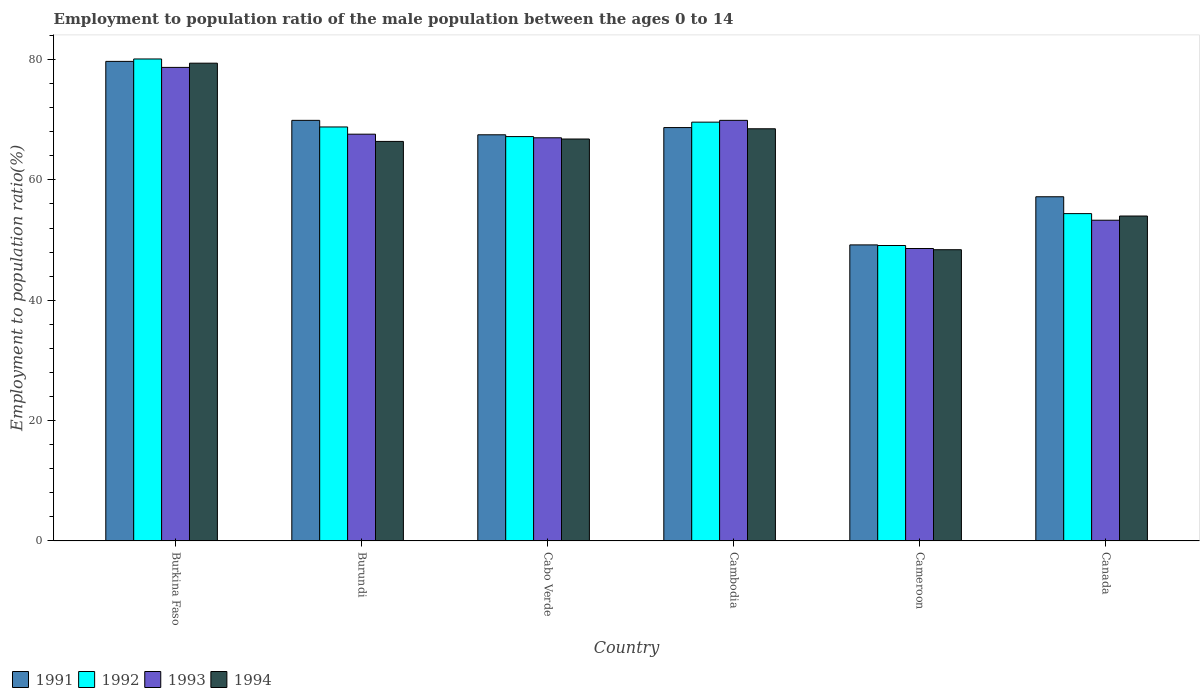How many different coloured bars are there?
Ensure brevity in your answer.  4. How many bars are there on the 5th tick from the left?
Give a very brief answer. 4. What is the label of the 3rd group of bars from the left?
Offer a terse response. Cabo Verde. What is the employment to population ratio in 1993 in Canada?
Give a very brief answer. 53.3. Across all countries, what is the maximum employment to population ratio in 1993?
Offer a terse response. 78.7. Across all countries, what is the minimum employment to population ratio in 1992?
Offer a very short reply. 49.1. In which country was the employment to population ratio in 1994 maximum?
Give a very brief answer. Burkina Faso. In which country was the employment to population ratio in 1993 minimum?
Ensure brevity in your answer.  Cameroon. What is the total employment to population ratio in 1993 in the graph?
Offer a very short reply. 385.1. What is the difference between the employment to population ratio in 1994 in Cabo Verde and that in Cameroon?
Keep it short and to the point. 18.4. What is the difference between the employment to population ratio in 1992 in Canada and the employment to population ratio in 1991 in Cabo Verde?
Provide a succinct answer. -13.1. What is the average employment to population ratio in 1991 per country?
Offer a terse response. 65.37. What is the difference between the employment to population ratio of/in 1991 and employment to population ratio of/in 1994 in Burkina Faso?
Provide a succinct answer. 0.3. In how many countries, is the employment to population ratio in 1993 greater than 24 %?
Your response must be concise. 6. What is the ratio of the employment to population ratio in 1994 in Burundi to that in Cambodia?
Keep it short and to the point. 0.97. Is the difference between the employment to population ratio in 1991 in Cambodia and Canada greater than the difference between the employment to population ratio in 1994 in Cambodia and Canada?
Your answer should be very brief. No. What is the difference between the highest and the second highest employment to population ratio in 1992?
Make the answer very short. 11.3. What is the difference between the highest and the lowest employment to population ratio in 1994?
Your response must be concise. 31. In how many countries, is the employment to population ratio in 1992 greater than the average employment to population ratio in 1992 taken over all countries?
Give a very brief answer. 4. Is the sum of the employment to population ratio in 1993 in Burundi and Cambodia greater than the maximum employment to population ratio in 1991 across all countries?
Offer a very short reply. Yes. Is it the case that in every country, the sum of the employment to population ratio in 1992 and employment to population ratio in 1991 is greater than the sum of employment to population ratio in 1994 and employment to population ratio in 1993?
Your answer should be compact. No. What does the 3rd bar from the left in Burkina Faso represents?
Provide a short and direct response. 1993. How many bars are there?
Keep it short and to the point. 24. How many countries are there in the graph?
Make the answer very short. 6. What is the difference between two consecutive major ticks on the Y-axis?
Offer a terse response. 20. Are the values on the major ticks of Y-axis written in scientific E-notation?
Keep it short and to the point. No. Does the graph contain grids?
Offer a very short reply. No. Where does the legend appear in the graph?
Give a very brief answer. Bottom left. How are the legend labels stacked?
Provide a short and direct response. Horizontal. What is the title of the graph?
Offer a very short reply. Employment to population ratio of the male population between the ages 0 to 14. What is the Employment to population ratio(%) in 1991 in Burkina Faso?
Your response must be concise. 79.7. What is the Employment to population ratio(%) in 1992 in Burkina Faso?
Keep it short and to the point. 80.1. What is the Employment to population ratio(%) in 1993 in Burkina Faso?
Offer a very short reply. 78.7. What is the Employment to population ratio(%) of 1994 in Burkina Faso?
Give a very brief answer. 79.4. What is the Employment to population ratio(%) in 1991 in Burundi?
Offer a terse response. 69.9. What is the Employment to population ratio(%) in 1992 in Burundi?
Give a very brief answer. 68.8. What is the Employment to population ratio(%) in 1993 in Burundi?
Provide a succinct answer. 67.6. What is the Employment to population ratio(%) in 1994 in Burundi?
Your answer should be compact. 66.4. What is the Employment to population ratio(%) in 1991 in Cabo Verde?
Offer a terse response. 67.5. What is the Employment to population ratio(%) of 1992 in Cabo Verde?
Your response must be concise. 67.2. What is the Employment to population ratio(%) of 1994 in Cabo Verde?
Offer a very short reply. 66.8. What is the Employment to population ratio(%) in 1991 in Cambodia?
Make the answer very short. 68.7. What is the Employment to population ratio(%) of 1992 in Cambodia?
Your answer should be compact. 69.6. What is the Employment to population ratio(%) in 1993 in Cambodia?
Make the answer very short. 69.9. What is the Employment to population ratio(%) in 1994 in Cambodia?
Give a very brief answer. 68.5. What is the Employment to population ratio(%) of 1991 in Cameroon?
Your answer should be very brief. 49.2. What is the Employment to population ratio(%) of 1992 in Cameroon?
Make the answer very short. 49.1. What is the Employment to population ratio(%) in 1993 in Cameroon?
Provide a succinct answer. 48.6. What is the Employment to population ratio(%) in 1994 in Cameroon?
Your response must be concise. 48.4. What is the Employment to population ratio(%) of 1991 in Canada?
Provide a succinct answer. 57.2. What is the Employment to population ratio(%) of 1992 in Canada?
Offer a very short reply. 54.4. What is the Employment to population ratio(%) of 1993 in Canada?
Offer a very short reply. 53.3. What is the Employment to population ratio(%) of 1994 in Canada?
Offer a terse response. 54. Across all countries, what is the maximum Employment to population ratio(%) of 1991?
Offer a very short reply. 79.7. Across all countries, what is the maximum Employment to population ratio(%) in 1992?
Your answer should be very brief. 80.1. Across all countries, what is the maximum Employment to population ratio(%) in 1993?
Offer a very short reply. 78.7. Across all countries, what is the maximum Employment to population ratio(%) of 1994?
Your answer should be compact. 79.4. Across all countries, what is the minimum Employment to population ratio(%) in 1991?
Make the answer very short. 49.2. Across all countries, what is the minimum Employment to population ratio(%) in 1992?
Your answer should be compact. 49.1. Across all countries, what is the minimum Employment to population ratio(%) in 1993?
Keep it short and to the point. 48.6. Across all countries, what is the minimum Employment to population ratio(%) in 1994?
Provide a short and direct response. 48.4. What is the total Employment to population ratio(%) in 1991 in the graph?
Your answer should be compact. 392.2. What is the total Employment to population ratio(%) in 1992 in the graph?
Provide a succinct answer. 389.2. What is the total Employment to population ratio(%) of 1993 in the graph?
Your response must be concise. 385.1. What is the total Employment to population ratio(%) in 1994 in the graph?
Offer a very short reply. 383.5. What is the difference between the Employment to population ratio(%) in 1991 in Burkina Faso and that in Burundi?
Provide a short and direct response. 9.8. What is the difference between the Employment to population ratio(%) of 1994 in Burkina Faso and that in Burundi?
Offer a very short reply. 13. What is the difference between the Employment to population ratio(%) of 1992 in Burkina Faso and that in Cabo Verde?
Your response must be concise. 12.9. What is the difference between the Employment to population ratio(%) of 1994 in Burkina Faso and that in Cabo Verde?
Ensure brevity in your answer.  12.6. What is the difference between the Employment to population ratio(%) of 1991 in Burkina Faso and that in Cambodia?
Make the answer very short. 11. What is the difference between the Employment to population ratio(%) of 1993 in Burkina Faso and that in Cambodia?
Your answer should be compact. 8.8. What is the difference between the Employment to population ratio(%) of 1991 in Burkina Faso and that in Cameroon?
Your answer should be very brief. 30.5. What is the difference between the Employment to population ratio(%) of 1992 in Burkina Faso and that in Cameroon?
Your answer should be compact. 31. What is the difference between the Employment to population ratio(%) in 1993 in Burkina Faso and that in Cameroon?
Offer a very short reply. 30.1. What is the difference between the Employment to population ratio(%) of 1991 in Burkina Faso and that in Canada?
Ensure brevity in your answer.  22.5. What is the difference between the Employment to population ratio(%) in 1992 in Burkina Faso and that in Canada?
Offer a terse response. 25.7. What is the difference between the Employment to population ratio(%) of 1993 in Burkina Faso and that in Canada?
Provide a succinct answer. 25.4. What is the difference between the Employment to population ratio(%) in 1994 in Burkina Faso and that in Canada?
Your answer should be compact. 25.4. What is the difference between the Employment to population ratio(%) of 1991 in Burundi and that in Cabo Verde?
Your answer should be compact. 2.4. What is the difference between the Employment to population ratio(%) in 1992 in Burundi and that in Cabo Verde?
Provide a short and direct response. 1.6. What is the difference between the Employment to population ratio(%) of 1993 in Burundi and that in Cabo Verde?
Give a very brief answer. 0.6. What is the difference between the Employment to population ratio(%) of 1994 in Burundi and that in Cabo Verde?
Your answer should be compact. -0.4. What is the difference between the Employment to population ratio(%) in 1994 in Burundi and that in Cambodia?
Offer a very short reply. -2.1. What is the difference between the Employment to population ratio(%) in 1991 in Burundi and that in Cameroon?
Offer a terse response. 20.7. What is the difference between the Employment to population ratio(%) in 1992 in Burundi and that in Canada?
Keep it short and to the point. 14.4. What is the difference between the Employment to population ratio(%) of 1991 in Cabo Verde and that in Cambodia?
Provide a succinct answer. -1.2. What is the difference between the Employment to population ratio(%) in 1993 in Cabo Verde and that in Cambodia?
Offer a terse response. -2.9. What is the difference between the Employment to population ratio(%) in 1994 in Cabo Verde and that in Cambodia?
Make the answer very short. -1.7. What is the difference between the Employment to population ratio(%) of 1991 in Cabo Verde and that in Cameroon?
Your answer should be very brief. 18.3. What is the difference between the Employment to population ratio(%) of 1992 in Cabo Verde and that in Cameroon?
Offer a very short reply. 18.1. What is the difference between the Employment to population ratio(%) in 1993 in Cabo Verde and that in Cameroon?
Your response must be concise. 18.4. What is the difference between the Employment to population ratio(%) of 1992 in Cabo Verde and that in Canada?
Offer a very short reply. 12.8. What is the difference between the Employment to population ratio(%) of 1994 in Cabo Verde and that in Canada?
Your response must be concise. 12.8. What is the difference between the Employment to population ratio(%) in 1991 in Cambodia and that in Cameroon?
Make the answer very short. 19.5. What is the difference between the Employment to population ratio(%) in 1993 in Cambodia and that in Cameroon?
Give a very brief answer. 21.3. What is the difference between the Employment to population ratio(%) of 1994 in Cambodia and that in Cameroon?
Give a very brief answer. 20.1. What is the difference between the Employment to population ratio(%) of 1991 in Cambodia and that in Canada?
Provide a short and direct response. 11.5. What is the difference between the Employment to population ratio(%) of 1994 in Cambodia and that in Canada?
Make the answer very short. 14.5. What is the difference between the Employment to population ratio(%) in 1993 in Cameroon and that in Canada?
Your answer should be very brief. -4.7. What is the difference between the Employment to population ratio(%) in 1992 in Burkina Faso and the Employment to population ratio(%) in 1993 in Burundi?
Offer a terse response. 12.5. What is the difference between the Employment to population ratio(%) in 1992 in Burkina Faso and the Employment to population ratio(%) in 1994 in Burundi?
Your answer should be compact. 13.7. What is the difference between the Employment to population ratio(%) in 1993 in Burkina Faso and the Employment to population ratio(%) in 1994 in Burundi?
Offer a very short reply. 12.3. What is the difference between the Employment to population ratio(%) in 1991 in Burkina Faso and the Employment to population ratio(%) in 1994 in Cabo Verde?
Provide a succinct answer. 12.9. What is the difference between the Employment to population ratio(%) of 1992 in Burkina Faso and the Employment to population ratio(%) of 1993 in Cabo Verde?
Your response must be concise. 13.1. What is the difference between the Employment to population ratio(%) of 1991 in Burkina Faso and the Employment to population ratio(%) of 1993 in Cambodia?
Give a very brief answer. 9.8. What is the difference between the Employment to population ratio(%) in 1991 in Burkina Faso and the Employment to population ratio(%) in 1994 in Cambodia?
Keep it short and to the point. 11.2. What is the difference between the Employment to population ratio(%) of 1993 in Burkina Faso and the Employment to population ratio(%) of 1994 in Cambodia?
Ensure brevity in your answer.  10.2. What is the difference between the Employment to population ratio(%) in 1991 in Burkina Faso and the Employment to population ratio(%) in 1992 in Cameroon?
Your answer should be compact. 30.6. What is the difference between the Employment to population ratio(%) of 1991 in Burkina Faso and the Employment to population ratio(%) of 1993 in Cameroon?
Offer a very short reply. 31.1. What is the difference between the Employment to population ratio(%) of 1991 in Burkina Faso and the Employment to population ratio(%) of 1994 in Cameroon?
Your answer should be very brief. 31.3. What is the difference between the Employment to population ratio(%) of 1992 in Burkina Faso and the Employment to population ratio(%) of 1993 in Cameroon?
Offer a terse response. 31.5. What is the difference between the Employment to population ratio(%) in 1992 in Burkina Faso and the Employment to population ratio(%) in 1994 in Cameroon?
Give a very brief answer. 31.7. What is the difference between the Employment to population ratio(%) of 1993 in Burkina Faso and the Employment to population ratio(%) of 1994 in Cameroon?
Ensure brevity in your answer.  30.3. What is the difference between the Employment to population ratio(%) in 1991 in Burkina Faso and the Employment to population ratio(%) in 1992 in Canada?
Make the answer very short. 25.3. What is the difference between the Employment to population ratio(%) in 1991 in Burkina Faso and the Employment to population ratio(%) in 1993 in Canada?
Keep it short and to the point. 26.4. What is the difference between the Employment to population ratio(%) in 1991 in Burkina Faso and the Employment to population ratio(%) in 1994 in Canada?
Offer a terse response. 25.7. What is the difference between the Employment to population ratio(%) of 1992 in Burkina Faso and the Employment to population ratio(%) of 1993 in Canada?
Provide a succinct answer. 26.8. What is the difference between the Employment to population ratio(%) in 1992 in Burkina Faso and the Employment to population ratio(%) in 1994 in Canada?
Your answer should be very brief. 26.1. What is the difference between the Employment to population ratio(%) of 1993 in Burkina Faso and the Employment to population ratio(%) of 1994 in Canada?
Provide a succinct answer. 24.7. What is the difference between the Employment to population ratio(%) in 1991 in Burundi and the Employment to population ratio(%) in 1993 in Cabo Verde?
Your answer should be very brief. 2.9. What is the difference between the Employment to population ratio(%) of 1991 in Burundi and the Employment to population ratio(%) of 1994 in Cabo Verde?
Your answer should be very brief. 3.1. What is the difference between the Employment to population ratio(%) in 1992 in Burundi and the Employment to population ratio(%) in 1993 in Cabo Verde?
Offer a terse response. 1.8. What is the difference between the Employment to population ratio(%) in 1992 in Burundi and the Employment to population ratio(%) in 1994 in Cabo Verde?
Make the answer very short. 2. What is the difference between the Employment to population ratio(%) in 1993 in Burundi and the Employment to population ratio(%) in 1994 in Cabo Verde?
Your answer should be very brief. 0.8. What is the difference between the Employment to population ratio(%) in 1991 in Burundi and the Employment to population ratio(%) in 1992 in Cambodia?
Offer a terse response. 0.3. What is the difference between the Employment to population ratio(%) in 1991 in Burundi and the Employment to population ratio(%) in 1993 in Cambodia?
Your answer should be very brief. 0. What is the difference between the Employment to population ratio(%) in 1991 in Burundi and the Employment to population ratio(%) in 1994 in Cambodia?
Keep it short and to the point. 1.4. What is the difference between the Employment to population ratio(%) in 1992 in Burundi and the Employment to population ratio(%) in 1994 in Cambodia?
Provide a short and direct response. 0.3. What is the difference between the Employment to population ratio(%) in 1993 in Burundi and the Employment to population ratio(%) in 1994 in Cambodia?
Provide a succinct answer. -0.9. What is the difference between the Employment to population ratio(%) of 1991 in Burundi and the Employment to population ratio(%) of 1992 in Cameroon?
Give a very brief answer. 20.8. What is the difference between the Employment to population ratio(%) in 1991 in Burundi and the Employment to population ratio(%) in 1993 in Cameroon?
Your answer should be very brief. 21.3. What is the difference between the Employment to population ratio(%) in 1991 in Burundi and the Employment to population ratio(%) in 1994 in Cameroon?
Ensure brevity in your answer.  21.5. What is the difference between the Employment to population ratio(%) in 1992 in Burundi and the Employment to population ratio(%) in 1993 in Cameroon?
Your response must be concise. 20.2. What is the difference between the Employment to population ratio(%) of 1992 in Burundi and the Employment to population ratio(%) of 1994 in Cameroon?
Ensure brevity in your answer.  20.4. What is the difference between the Employment to population ratio(%) of 1991 in Burundi and the Employment to population ratio(%) of 1992 in Canada?
Give a very brief answer. 15.5. What is the difference between the Employment to population ratio(%) in 1991 in Burundi and the Employment to population ratio(%) in 1993 in Canada?
Offer a terse response. 16.6. What is the difference between the Employment to population ratio(%) in 1991 in Burundi and the Employment to population ratio(%) in 1994 in Canada?
Your response must be concise. 15.9. What is the difference between the Employment to population ratio(%) of 1992 in Burundi and the Employment to population ratio(%) of 1994 in Canada?
Your answer should be compact. 14.8. What is the difference between the Employment to population ratio(%) in 1993 in Burundi and the Employment to population ratio(%) in 1994 in Canada?
Give a very brief answer. 13.6. What is the difference between the Employment to population ratio(%) in 1991 in Cabo Verde and the Employment to population ratio(%) in 1992 in Cambodia?
Make the answer very short. -2.1. What is the difference between the Employment to population ratio(%) of 1991 in Cabo Verde and the Employment to population ratio(%) of 1994 in Cambodia?
Give a very brief answer. -1. What is the difference between the Employment to population ratio(%) in 1992 in Cabo Verde and the Employment to population ratio(%) in 1993 in Cambodia?
Your answer should be compact. -2.7. What is the difference between the Employment to population ratio(%) in 1991 in Cabo Verde and the Employment to population ratio(%) in 1994 in Cameroon?
Give a very brief answer. 19.1. What is the difference between the Employment to population ratio(%) in 1992 in Cabo Verde and the Employment to population ratio(%) in 1993 in Cameroon?
Offer a terse response. 18.6. What is the difference between the Employment to population ratio(%) of 1992 in Cabo Verde and the Employment to population ratio(%) of 1994 in Cameroon?
Make the answer very short. 18.8. What is the difference between the Employment to population ratio(%) in 1991 in Cabo Verde and the Employment to population ratio(%) in 1993 in Canada?
Your answer should be compact. 14.2. What is the difference between the Employment to population ratio(%) of 1991 in Cabo Verde and the Employment to population ratio(%) of 1994 in Canada?
Provide a succinct answer. 13.5. What is the difference between the Employment to population ratio(%) in 1992 in Cabo Verde and the Employment to population ratio(%) in 1993 in Canada?
Your response must be concise. 13.9. What is the difference between the Employment to population ratio(%) of 1992 in Cabo Verde and the Employment to population ratio(%) of 1994 in Canada?
Your answer should be very brief. 13.2. What is the difference between the Employment to population ratio(%) of 1993 in Cabo Verde and the Employment to population ratio(%) of 1994 in Canada?
Keep it short and to the point. 13. What is the difference between the Employment to population ratio(%) of 1991 in Cambodia and the Employment to population ratio(%) of 1992 in Cameroon?
Ensure brevity in your answer.  19.6. What is the difference between the Employment to population ratio(%) in 1991 in Cambodia and the Employment to population ratio(%) in 1993 in Cameroon?
Your answer should be very brief. 20.1. What is the difference between the Employment to population ratio(%) in 1991 in Cambodia and the Employment to population ratio(%) in 1994 in Cameroon?
Provide a succinct answer. 20.3. What is the difference between the Employment to population ratio(%) of 1992 in Cambodia and the Employment to population ratio(%) of 1994 in Cameroon?
Keep it short and to the point. 21.2. What is the difference between the Employment to population ratio(%) in 1993 in Cambodia and the Employment to population ratio(%) in 1994 in Cameroon?
Provide a succinct answer. 21.5. What is the difference between the Employment to population ratio(%) in 1992 in Cambodia and the Employment to population ratio(%) in 1993 in Canada?
Offer a very short reply. 16.3. What is the difference between the Employment to population ratio(%) in 1992 in Cambodia and the Employment to population ratio(%) in 1994 in Canada?
Provide a short and direct response. 15.6. What is the difference between the Employment to population ratio(%) in 1991 in Cameroon and the Employment to population ratio(%) in 1992 in Canada?
Give a very brief answer. -5.2. What is the difference between the Employment to population ratio(%) of 1991 in Cameroon and the Employment to population ratio(%) of 1994 in Canada?
Your answer should be very brief. -4.8. What is the difference between the Employment to population ratio(%) of 1992 in Cameroon and the Employment to population ratio(%) of 1994 in Canada?
Your answer should be compact. -4.9. What is the average Employment to population ratio(%) in 1991 per country?
Your answer should be compact. 65.37. What is the average Employment to population ratio(%) of 1992 per country?
Your response must be concise. 64.87. What is the average Employment to population ratio(%) in 1993 per country?
Give a very brief answer. 64.18. What is the average Employment to population ratio(%) in 1994 per country?
Your response must be concise. 63.92. What is the difference between the Employment to population ratio(%) of 1991 and Employment to population ratio(%) of 1992 in Burkina Faso?
Offer a very short reply. -0.4. What is the difference between the Employment to population ratio(%) in 1991 and Employment to population ratio(%) in 1994 in Burkina Faso?
Provide a short and direct response. 0.3. What is the difference between the Employment to population ratio(%) of 1992 and Employment to population ratio(%) of 1993 in Burundi?
Your answer should be very brief. 1.2. What is the difference between the Employment to population ratio(%) in 1991 and Employment to population ratio(%) in 1992 in Cabo Verde?
Give a very brief answer. 0.3. What is the difference between the Employment to population ratio(%) of 1992 and Employment to population ratio(%) of 1993 in Cabo Verde?
Your answer should be compact. 0.2. What is the difference between the Employment to population ratio(%) in 1992 and Employment to population ratio(%) in 1994 in Cabo Verde?
Make the answer very short. 0.4. What is the difference between the Employment to population ratio(%) in 1993 and Employment to population ratio(%) in 1994 in Cabo Verde?
Provide a short and direct response. 0.2. What is the difference between the Employment to population ratio(%) of 1991 and Employment to population ratio(%) of 1993 in Cambodia?
Your response must be concise. -1.2. What is the difference between the Employment to population ratio(%) of 1991 and Employment to population ratio(%) of 1994 in Cambodia?
Provide a short and direct response. 0.2. What is the difference between the Employment to population ratio(%) of 1993 and Employment to population ratio(%) of 1994 in Cambodia?
Make the answer very short. 1.4. What is the difference between the Employment to population ratio(%) of 1991 and Employment to population ratio(%) of 1993 in Cameroon?
Your answer should be compact. 0.6. What is the difference between the Employment to population ratio(%) in 1992 and Employment to population ratio(%) in 1993 in Cameroon?
Offer a very short reply. 0.5. What is the difference between the Employment to population ratio(%) in 1993 and Employment to population ratio(%) in 1994 in Cameroon?
Ensure brevity in your answer.  0.2. What is the difference between the Employment to population ratio(%) in 1992 and Employment to population ratio(%) in 1994 in Canada?
Offer a terse response. 0.4. What is the difference between the Employment to population ratio(%) in 1993 and Employment to population ratio(%) in 1994 in Canada?
Your answer should be compact. -0.7. What is the ratio of the Employment to population ratio(%) in 1991 in Burkina Faso to that in Burundi?
Ensure brevity in your answer.  1.14. What is the ratio of the Employment to population ratio(%) of 1992 in Burkina Faso to that in Burundi?
Your answer should be very brief. 1.16. What is the ratio of the Employment to population ratio(%) of 1993 in Burkina Faso to that in Burundi?
Offer a terse response. 1.16. What is the ratio of the Employment to population ratio(%) of 1994 in Burkina Faso to that in Burundi?
Provide a succinct answer. 1.2. What is the ratio of the Employment to population ratio(%) in 1991 in Burkina Faso to that in Cabo Verde?
Your answer should be compact. 1.18. What is the ratio of the Employment to population ratio(%) of 1992 in Burkina Faso to that in Cabo Verde?
Your answer should be very brief. 1.19. What is the ratio of the Employment to population ratio(%) in 1993 in Burkina Faso to that in Cabo Verde?
Provide a short and direct response. 1.17. What is the ratio of the Employment to population ratio(%) in 1994 in Burkina Faso to that in Cabo Verde?
Ensure brevity in your answer.  1.19. What is the ratio of the Employment to population ratio(%) in 1991 in Burkina Faso to that in Cambodia?
Ensure brevity in your answer.  1.16. What is the ratio of the Employment to population ratio(%) of 1992 in Burkina Faso to that in Cambodia?
Make the answer very short. 1.15. What is the ratio of the Employment to population ratio(%) in 1993 in Burkina Faso to that in Cambodia?
Offer a terse response. 1.13. What is the ratio of the Employment to population ratio(%) in 1994 in Burkina Faso to that in Cambodia?
Your response must be concise. 1.16. What is the ratio of the Employment to population ratio(%) in 1991 in Burkina Faso to that in Cameroon?
Your answer should be very brief. 1.62. What is the ratio of the Employment to population ratio(%) of 1992 in Burkina Faso to that in Cameroon?
Offer a terse response. 1.63. What is the ratio of the Employment to population ratio(%) in 1993 in Burkina Faso to that in Cameroon?
Provide a succinct answer. 1.62. What is the ratio of the Employment to population ratio(%) in 1994 in Burkina Faso to that in Cameroon?
Give a very brief answer. 1.64. What is the ratio of the Employment to population ratio(%) of 1991 in Burkina Faso to that in Canada?
Ensure brevity in your answer.  1.39. What is the ratio of the Employment to population ratio(%) of 1992 in Burkina Faso to that in Canada?
Make the answer very short. 1.47. What is the ratio of the Employment to population ratio(%) in 1993 in Burkina Faso to that in Canada?
Ensure brevity in your answer.  1.48. What is the ratio of the Employment to population ratio(%) in 1994 in Burkina Faso to that in Canada?
Your answer should be very brief. 1.47. What is the ratio of the Employment to population ratio(%) of 1991 in Burundi to that in Cabo Verde?
Ensure brevity in your answer.  1.04. What is the ratio of the Employment to population ratio(%) of 1992 in Burundi to that in Cabo Verde?
Provide a short and direct response. 1.02. What is the ratio of the Employment to population ratio(%) of 1993 in Burundi to that in Cabo Verde?
Ensure brevity in your answer.  1.01. What is the ratio of the Employment to population ratio(%) in 1994 in Burundi to that in Cabo Verde?
Give a very brief answer. 0.99. What is the ratio of the Employment to population ratio(%) in 1991 in Burundi to that in Cambodia?
Offer a terse response. 1.02. What is the ratio of the Employment to population ratio(%) in 1992 in Burundi to that in Cambodia?
Offer a terse response. 0.99. What is the ratio of the Employment to population ratio(%) in 1993 in Burundi to that in Cambodia?
Your answer should be very brief. 0.97. What is the ratio of the Employment to population ratio(%) in 1994 in Burundi to that in Cambodia?
Give a very brief answer. 0.97. What is the ratio of the Employment to population ratio(%) in 1991 in Burundi to that in Cameroon?
Your answer should be very brief. 1.42. What is the ratio of the Employment to population ratio(%) of 1992 in Burundi to that in Cameroon?
Ensure brevity in your answer.  1.4. What is the ratio of the Employment to population ratio(%) of 1993 in Burundi to that in Cameroon?
Provide a succinct answer. 1.39. What is the ratio of the Employment to population ratio(%) of 1994 in Burundi to that in Cameroon?
Provide a succinct answer. 1.37. What is the ratio of the Employment to population ratio(%) of 1991 in Burundi to that in Canada?
Provide a succinct answer. 1.22. What is the ratio of the Employment to population ratio(%) in 1992 in Burundi to that in Canada?
Offer a terse response. 1.26. What is the ratio of the Employment to population ratio(%) of 1993 in Burundi to that in Canada?
Ensure brevity in your answer.  1.27. What is the ratio of the Employment to population ratio(%) in 1994 in Burundi to that in Canada?
Ensure brevity in your answer.  1.23. What is the ratio of the Employment to population ratio(%) of 1991 in Cabo Verde to that in Cambodia?
Ensure brevity in your answer.  0.98. What is the ratio of the Employment to population ratio(%) in 1992 in Cabo Verde to that in Cambodia?
Keep it short and to the point. 0.97. What is the ratio of the Employment to population ratio(%) of 1993 in Cabo Verde to that in Cambodia?
Give a very brief answer. 0.96. What is the ratio of the Employment to population ratio(%) of 1994 in Cabo Verde to that in Cambodia?
Keep it short and to the point. 0.98. What is the ratio of the Employment to population ratio(%) in 1991 in Cabo Verde to that in Cameroon?
Ensure brevity in your answer.  1.37. What is the ratio of the Employment to population ratio(%) in 1992 in Cabo Verde to that in Cameroon?
Your response must be concise. 1.37. What is the ratio of the Employment to population ratio(%) of 1993 in Cabo Verde to that in Cameroon?
Give a very brief answer. 1.38. What is the ratio of the Employment to population ratio(%) in 1994 in Cabo Verde to that in Cameroon?
Give a very brief answer. 1.38. What is the ratio of the Employment to population ratio(%) of 1991 in Cabo Verde to that in Canada?
Provide a succinct answer. 1.18. What is the ratio of the Employment to population ratio(%) of 1992 in Cabo Verde to that in Canada?
Make the answer very short. 1.24. What is the ratio of the Employment to population ratio(%) of 1993 in Cabo Verde to that in Canada?
Your answer should be compact. 1.26. What is the ratio of the Employment to population ratio(%) of 1994 in Cabo Verde to that in Canada?
Your response must be concise. 1.24. What is the ratio of the Employment to population ratio(%) in 1991 in Cambodia to that in Cameroon?
Provide a succinct answer. 1.4. What is the ratio of the Employment to population ratio(%) of 1992 in Cambodia to that in Cameroon?
Your response must be concise. 1.42. What is the ratio of the Employment to population ratio(%) of 1993 in Cambodia to that in Cameroon?
Keep it short and to the point. 1.44. What is the ratio of the Employment to population ratio(%) of 1994 in Cambodia to that in Cameroon?
Offer a terse response. 1.42. What is the ratio of the Employment to population ratio(%) in 1991 in Cambodia to that in Canada?
Provide a short and direct response. 1.2. What is the ratio of the Employment to population ratio(%) of 1992 in Cambodia to that in Canada?
Provide a succinct answer. 1.28. What is the ratio of the Employment to population ratio(%) of 1993 in Cambodia to that in Canada?
Keep it short and to the point. 1.31. What is the ratio of the Employment to population ratio(%) of 1994 in Cambodia to that in Canada?
Your answer should be compact. 1.27. What is the ratio of the Employment to population ratio(%) of 1991 in Cameroon to that in Canada?
Ensure brevity in your answer.  0.86. What is the ratio of the Employment to population ratio(%) in 1992 in Cameroon to that in Canada?
Give a very brief answer. 0.9. What is the ratio of the Employment to population ratio(%) in 1993 in Cameroon to that in Canada?
Ensure brevity in your answer.  0.91. What is the ratio of the Employment to population ratio(%) in 1994 in Cameroon to that in Canada?
Your answer should be compact. 0.9. What is the difference between the highest and the second highest Employment to population ratio(%) of 1991?
Provide a succinct answer. 9.8. What is the difference between the highest and the second highest Employment to population ratio(%) in 1992?
Provide a succinct answer. 10.5. What is the difference between the highest and the second highest Employment to population ratio(%) in 1993?
Make the answer very short. 8.8. What is the difference between the highest and the second highest Employment to population ratio(%) in 1994?
Give a very brief answer. 10.9. What is the difference between the highest and the lowest Employment to population ratio(%) of 1991?
Make the answer very short. 30.5. What is the difference between the highest and the lowest Employment to population ratio(%) in 1993?
Provide a short and direct response. 30.1. What is the difference between the highest and the lowest Employment to population ratio(%) of 1994?
Provide a short and direct response. 31. 